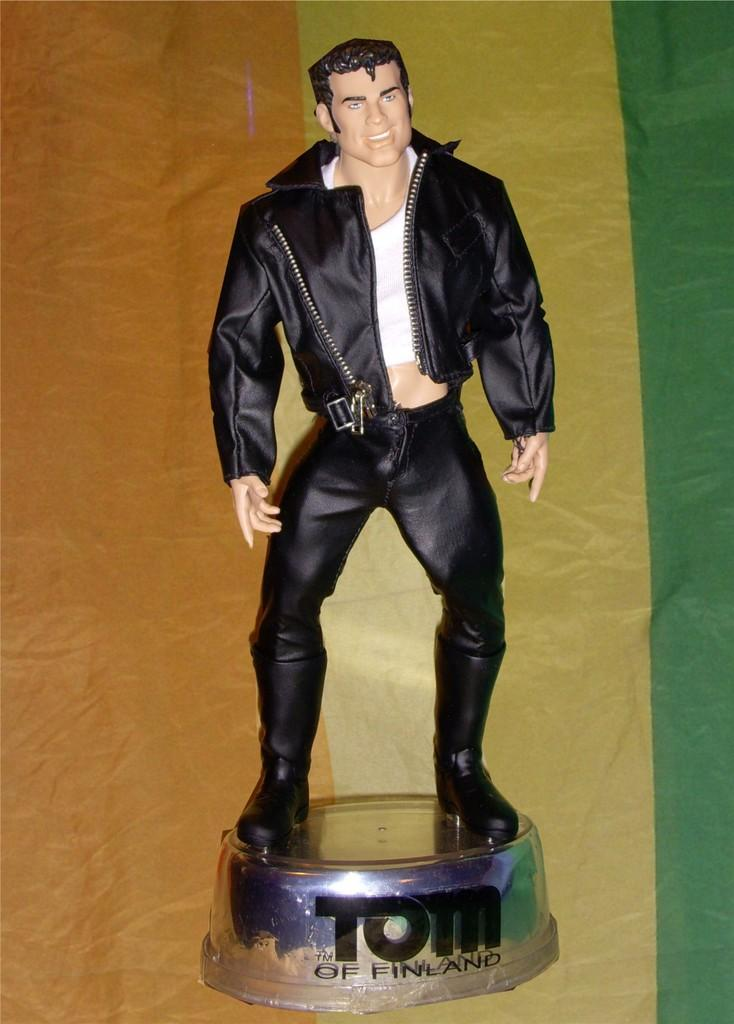What is the main subject of the image? There is a statue of a person in the image. What is the statue standing on? The statue is on a round shape object. Is there any text present in the image? Yes, there is text on the round shape object. What can be seen in the background of the image? There are different colors visible in the background of the image. Can you tell me how many thumbs are visible on the statue in the image? There are no thumbs visible on the statue in the image, as it is a statue and not a living person. What type of tub is located next to the statue in the image? There is no tub present in the image; it only features a statue on a round shape object with text. 